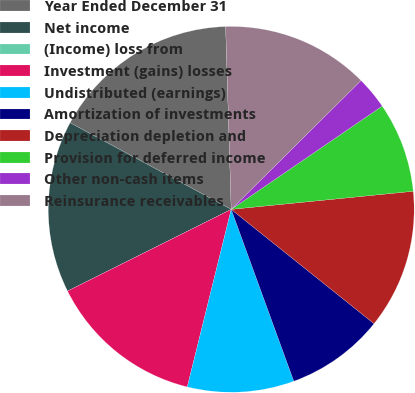Convert chart. <chart><loc_0><loc_0><loc_500><loc_500><pie_chart><fcel>Year Ended December 31<fcel>Net income<fcel>(Income) loss from<fcel>Investment (gains) losses<fcel>Undistributed (earnings)<fcel>Amortization of investments<fcel>Depreciation depletion and<fcel>Provision for deferred income<fcel>Other non-cash items<fcel>Reinsurance receivables<nl><fcel>16.67%<fcel>15.22%<fcel>0.0%<fcel>13.77%<fcel>9.42%<fcel>8.7%<fcel>12.32%<fcel>7.97%<fcel>2.9%<fcel>13.04%<nl></chart> 